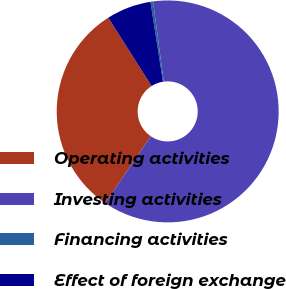<chart> <loc_0><loc_0><loc_500><loc_500><pie_chart><fcel>Operating activities<fcel>Investing activities<fcel>Financing activities<fcel>Effect of foreign exchange<nl><fcel>31.49%<fcel>61.63%<fcel>0.38%<fcel>6.51%<nl></chart> 